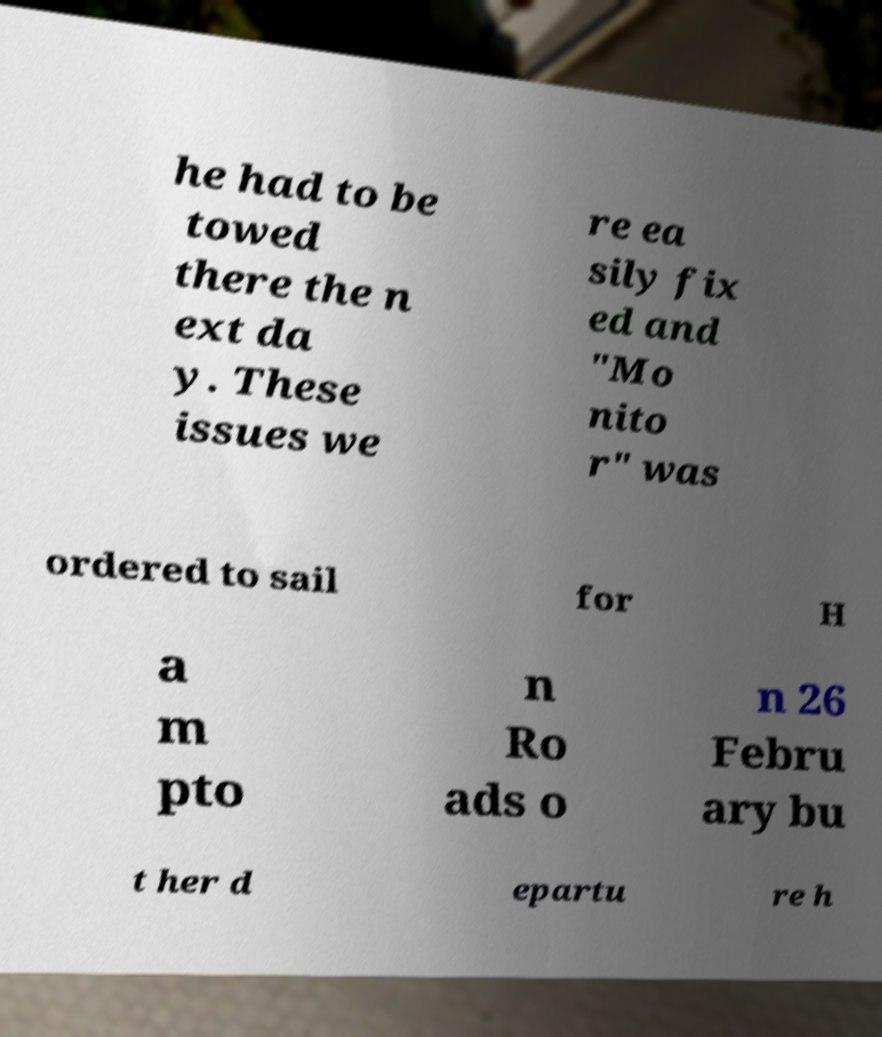What messages or text are displayed in this image? I need them in a readable, typed format. he had to be towed there the n ext da y. These issues we re ea sily fix ed and "Mo nito r" was ordered to sail for H a m pto n Ro ads o n 26 Febru ary bu t her d epartu re h 